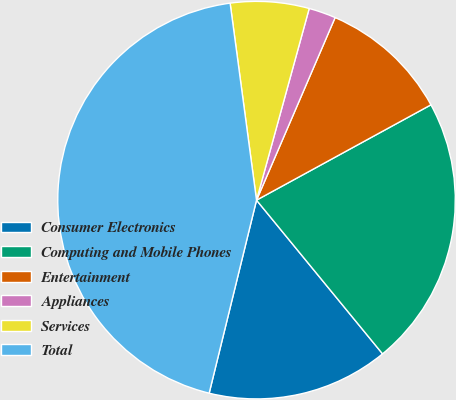Convert chart to OTSL. <chart><loc_0><loc_0><loc_500><loc_500><pie_chart><fcel>Consumer Electronics<fcel>Computing and Mobile Phones<fcel>Entertainment<fcel>Appliances<fcel>Services<fcel>Total<nl><fcel>14.76%<fcel>22.03%<fcel>10.57%<fcel>2.2%<fcel>6.39%<fcel>44.05%<nl></chart> 